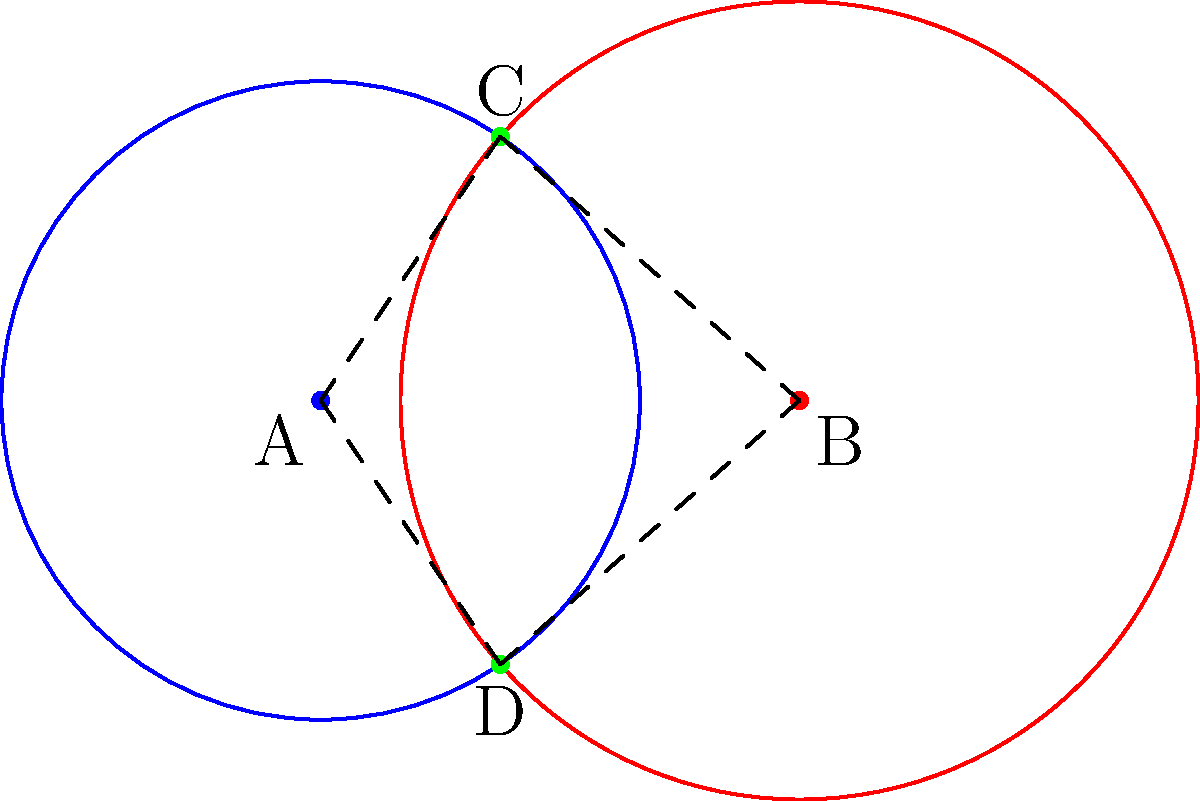Two energy fields are represented by overlapping circles with centers A and B. The radius of circle A is 2 units, and the radius of circle B is 2.5 units. The distance between their centers is 3 units. If points C and D represent the intersection of these energy fields, what is the area of triangle ACD? To find the area of triangle ACD, we'll follow these steps:

1) First, we need to find the coordinates of point C. We can do this using the equations of the two circles:

   Circle A: $x^2 + y^2 = 4$
   Circle B: $(x-3)^2 + y^2 = 6.25$

2) Solving these equations simultaneously:
   $x^2 + y^2 = 4$ ... (1)
   $x^2 - 6x + 9 + y^2 = 6.25$ ... (2)

   Subtracting (1) from (2):
   $-6x + 9 = 2.25$
   $-6x = -6.75$
   $x = 1.125$

3) Substituting this x-value back into equation (1):
   $(1.125)^2 + y^2 = 4$
   $y^2 = 4 - 1.265625 = 2.734375$
   $y = \pm \sqrt{2.734375} = \pm 1.65375$

4) So, the coordinates of C are (1.125, 1.65375)

5) Now we can use the formula for the area of a triangle given the coordinates of its vertices:
   Area = $\frac{1}{2}|x_1(y_2 - y_3) + x_2(y_3 - y_1) + x_3(y_1 - y_2)|$

   Where (x1,y1) = (0,0), (x2,y2) = (3,0), and (x3,y3) = (1.125, 1.65375)

6) Plugging in these values:
   Area = $\frac{1}{2}|0(0 - 1.65375) + 3(1.65375 - 0) + 1.125(0 - 0)|$
        = $\frac{1}{2}|0 + 4.96125 + 0|$
        = $\frac{1}{2}(4.96125)$
        = 2.480625

Therefore, the area of triangle ACD is approximately 2.48 square units.
Answer: 2.48 square units 